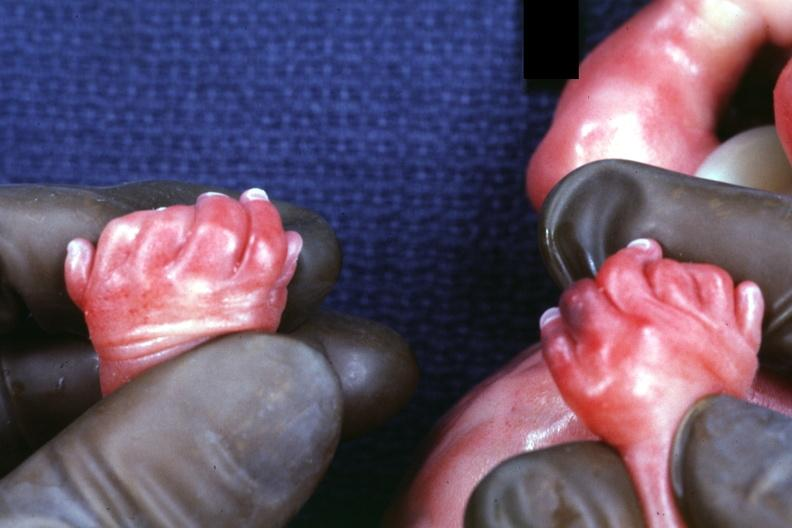what does child have?
Answer the question using a single word or phrase. Child 